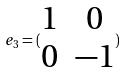<formula> <loc_0><loc_0><loc_500><loc_500>e _ { 3 } = ( \begin{matrix} 1 & 0 \\ 0 & - 1 \end{matrix} )</formula> 